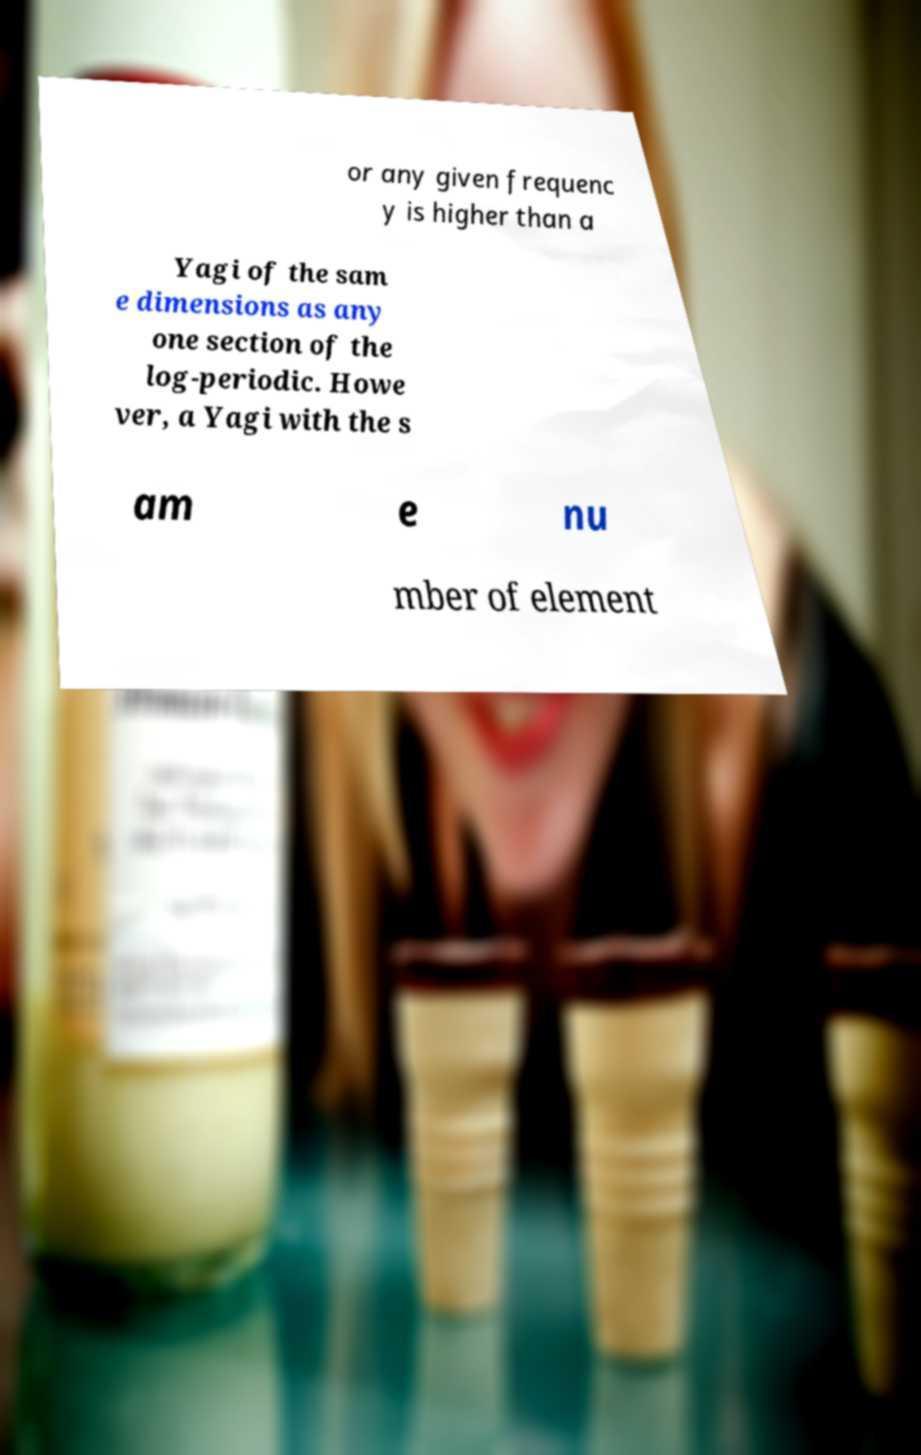There's text embedded in this image that I need extracted. Can you transcribe it verbatim? or any given frequenc y is higher than a Yagi of the sam e dimensions as any one section of the log-periodic. Howe ver, a Yagi with the s am e nu mber of element 